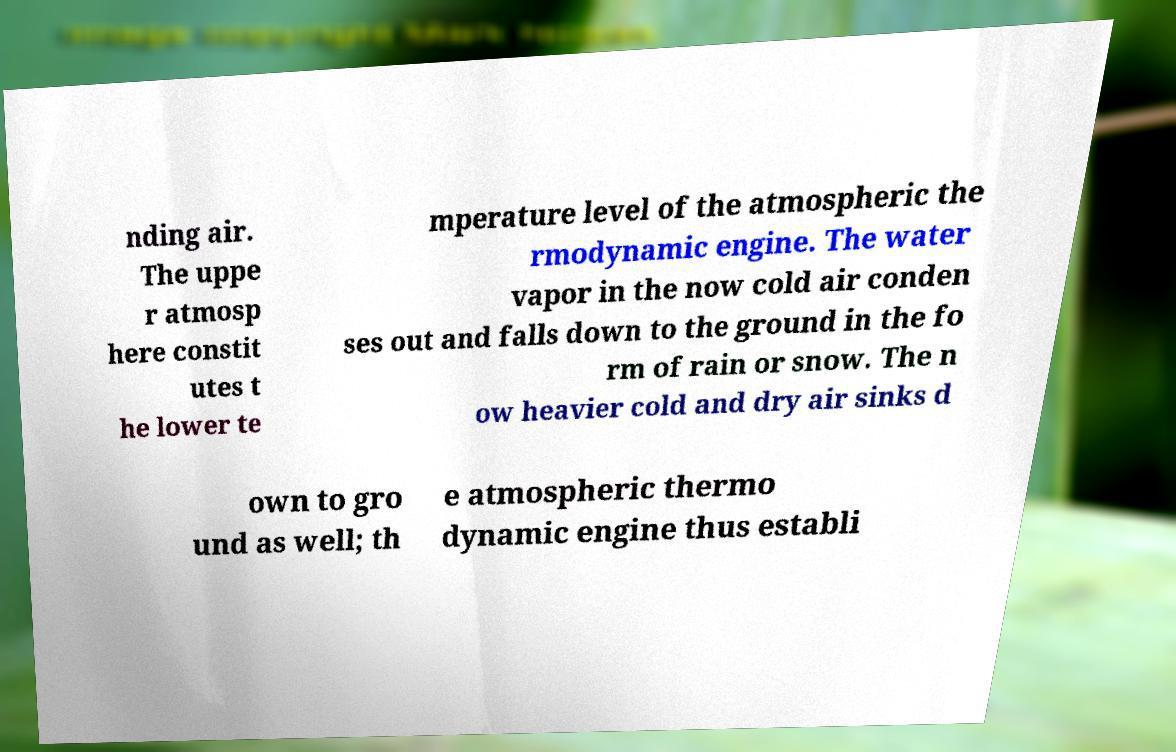Can you read and provide the text displayed in the image?This photo seems to have some interesting text. Can you extract and type it out for me? nding air. The uppe r atmosp here constit utes t he lower te mperature level of the atmospheric the rmodynamic engine. The water vapor in the now cold air conden ses out and falls down to the ground in the fo rm of rain or snow. The n ow heavier cold and dry air sinks d own to gro und as well; th e atmospheric thermo dynamic engine thus establi 